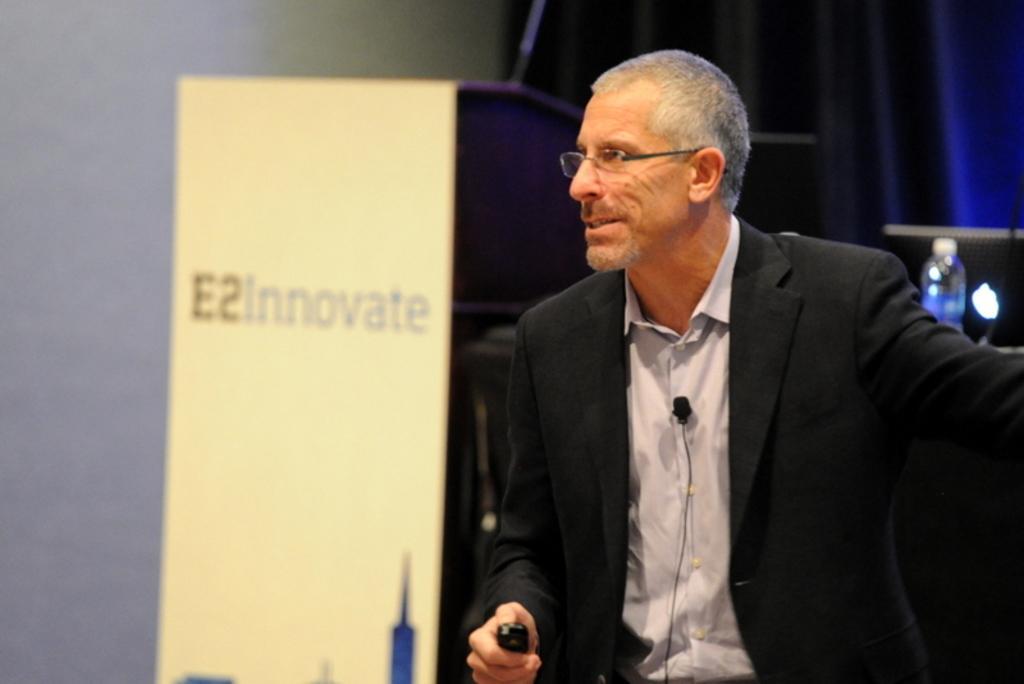How would you summarize this image in a sentence or two? In this image there is a man on the right side who is wearing the coat. Behind him there is a podium. On the right side there is a laptop and a bottle on the table in the background. There is a curtain at the top. There is a mic attached to his shirt. 